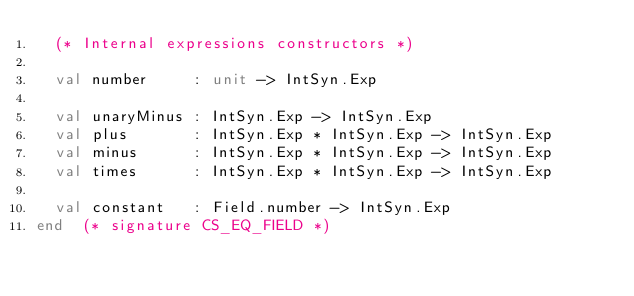<code> <loc_0><loc_0><loc_500><loc_500><_SML_>  (* Internal expressions constructors *)

  val number     : unit -> IntSyn.Exp

  val unaryMinus : IntSyn.Exp -> IntSyn.Exp
  val plus       : IntSyn.Exp * IntSyn.Exp -> IntSyn.Exp
  val minus      : IntSyn.Exp * IntSyn.Exp -> IntSyn.Exp
  val times      : IntSyn.Exp * IntSyn.Exp -> IntSyn.Exp

  val constant   : Field.number -> IntSyn.Exp
end  (* signature CS_EQ_FIELD *)
</code> 